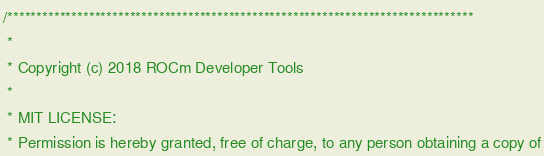<code> <loc_0><loc_0><loc_500><loc_500><_C++_>/********************************************************************************
 * 
 * Copyright (c) 2018 ROCm Developer Tools
 *
 * MIT LICENSE:
 * Permission is hereby granted, free of charge, to any person obtaining a copy of</code> 